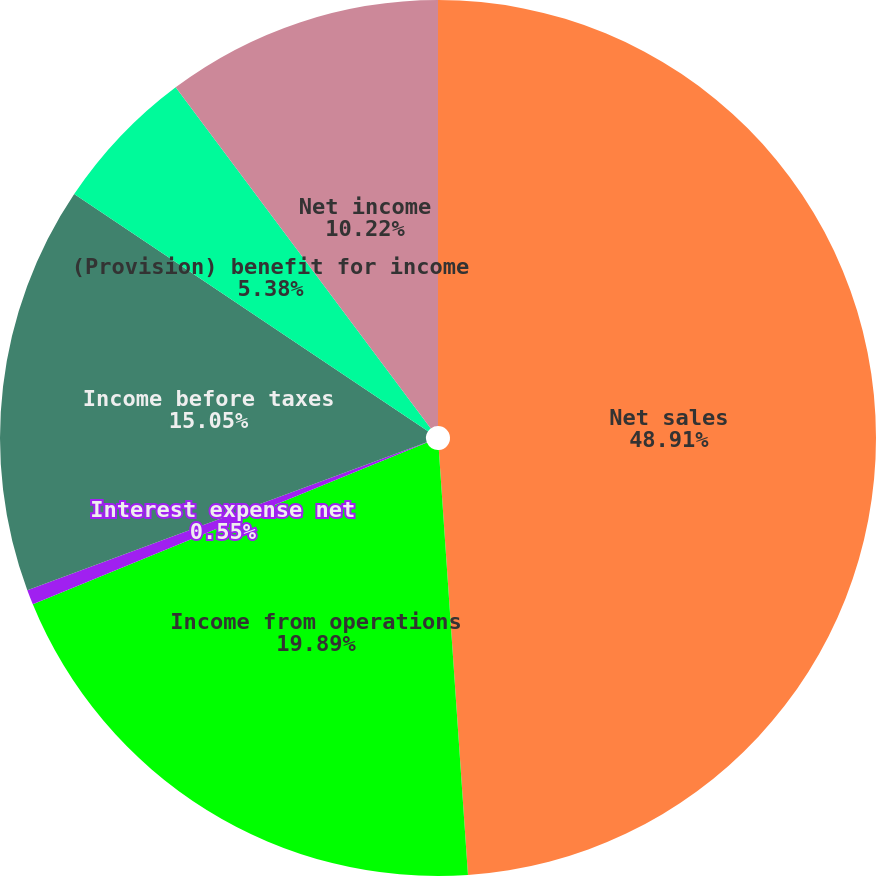<chart> <loc_0><loc_0><loc_500><loc_500><pie_chart><fcel>Net sales<fcel>Income from operations<fcel>Interest expense net<fcel>Income before taxes<fcel>(Provision) benefit for income<fcel>Net income<nl><fcel>48.91%<fcel>19.89%<fcel>0.55%<fcel>15.05%<fcel>5.38%<fcel>10.22%<nl></chart> 